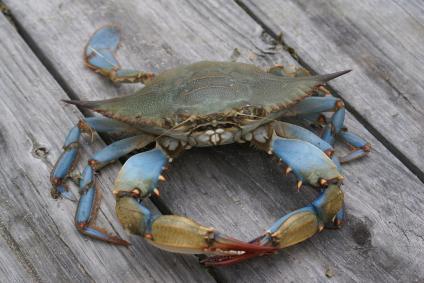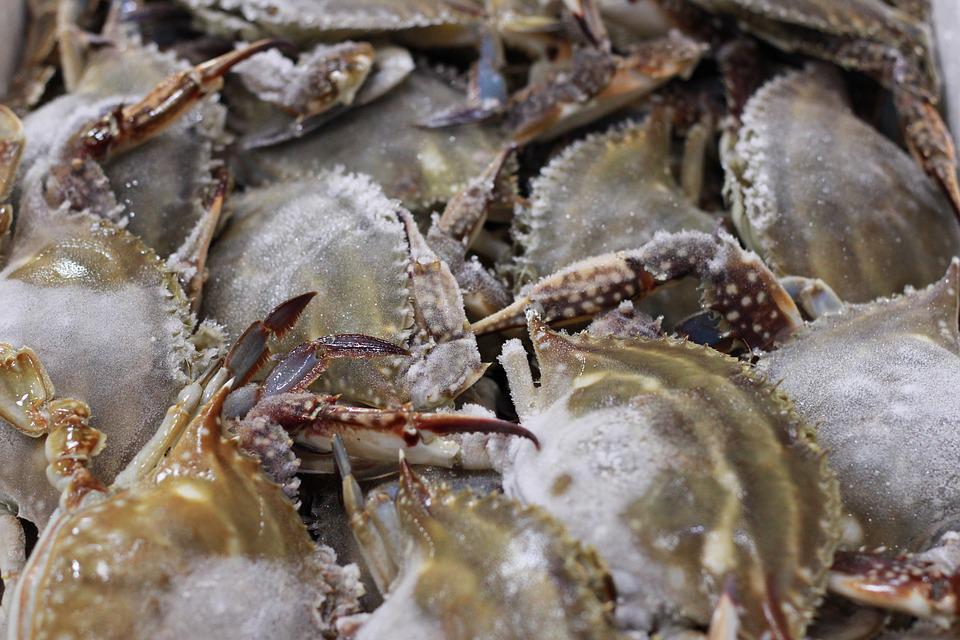The first image is the image on the left, the second image is the image on the right. Analyze the images presented: Is the assertion "IN at least one image there is at least one blue clawed crab sitting on a wooden dock." valid? Answer yes or no. Yes. The first image is the image on the left, the second image is the image on the right. For the images shown, is this caption "The left image contains one forward-facing crab with its top shell visible, and the right image contains a mass of crabs." true? Answer yes or no. Yes. 